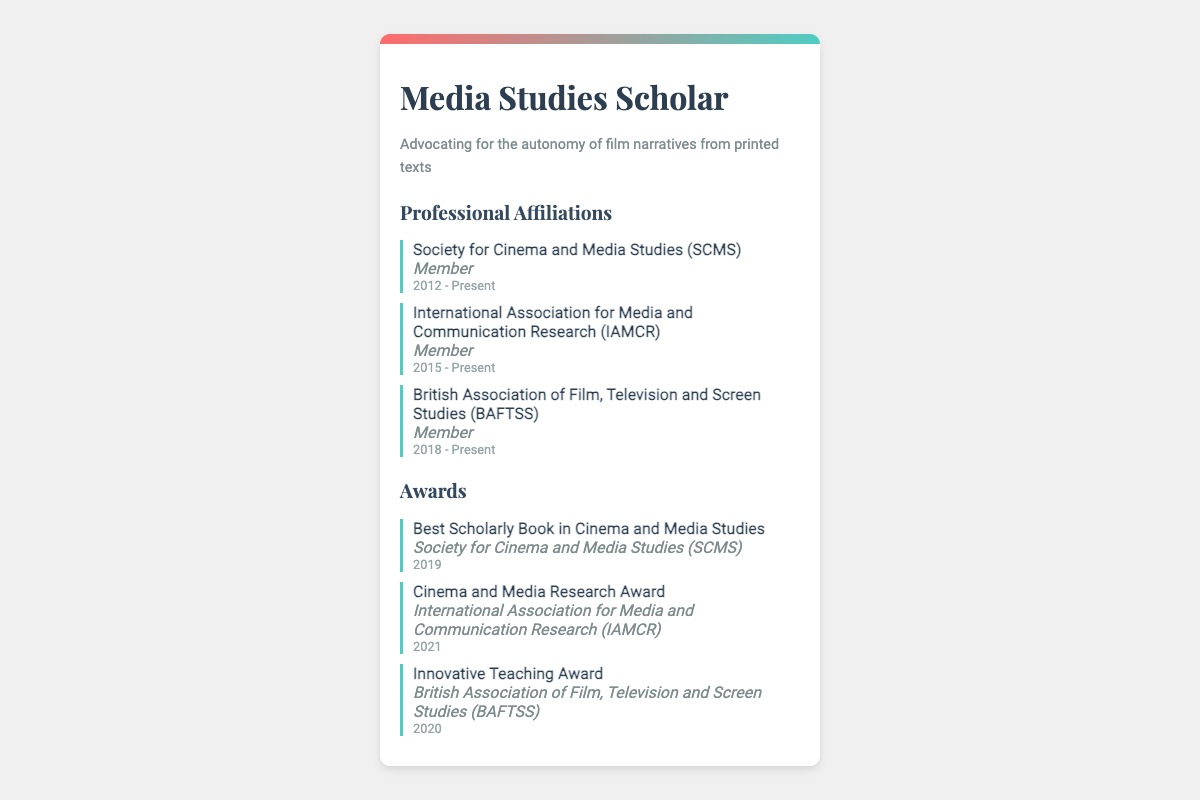What is the name of the first professional affiliation? The first professional affiliation listed is "Society for Cinema and Media Studies (SCMS)."
Answer: Society for Cinema and Media Studies (SCMS) What year did the scholar become a member of the International Association for Media and Communication Research? The document states that membership in this organization started in 2015 and is still ongoing.
Answer: 2015 Which award was received in 2021? The document highlights the "Cinema and Media Research Award" as the award received in 2021.
Answer: Cinema and Media Research Award How many professional affiliations are listed on the business card? The document includes three affiliations in total: SCMS, IAMCR, and BAFTSS.
Answer: Three Which organization issued the "Innovative Teaching Award"? The document specifies that the "Innovative Teaching Award" was issued by the British Association of Film, Television and Screen Studies (BAFTSS).
Answer: British Association of Film, Television and Screen Studies (BAFTSS) What is the role of the member in the Society for Cinema and Media Studies? The document indicates that the member's role is simply "Member" within the organization.
Answer: Member What is the duration of membership in the British Association of Film, Television and Screen Studies? According to the document, the member has been part of BAFTSS since 2018 and remains a member.
Answer: 2018 - Present 